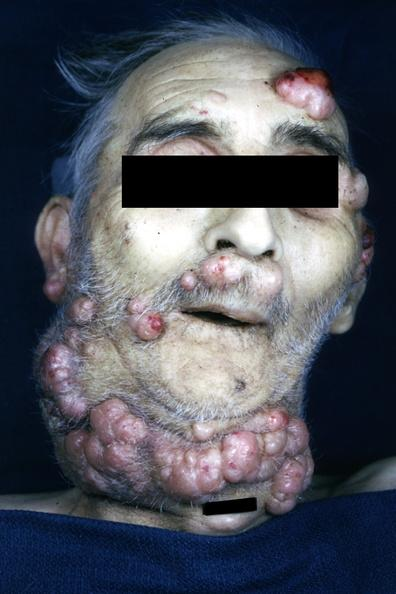where is this?
Answer the question using a single word or phrase. Skin 